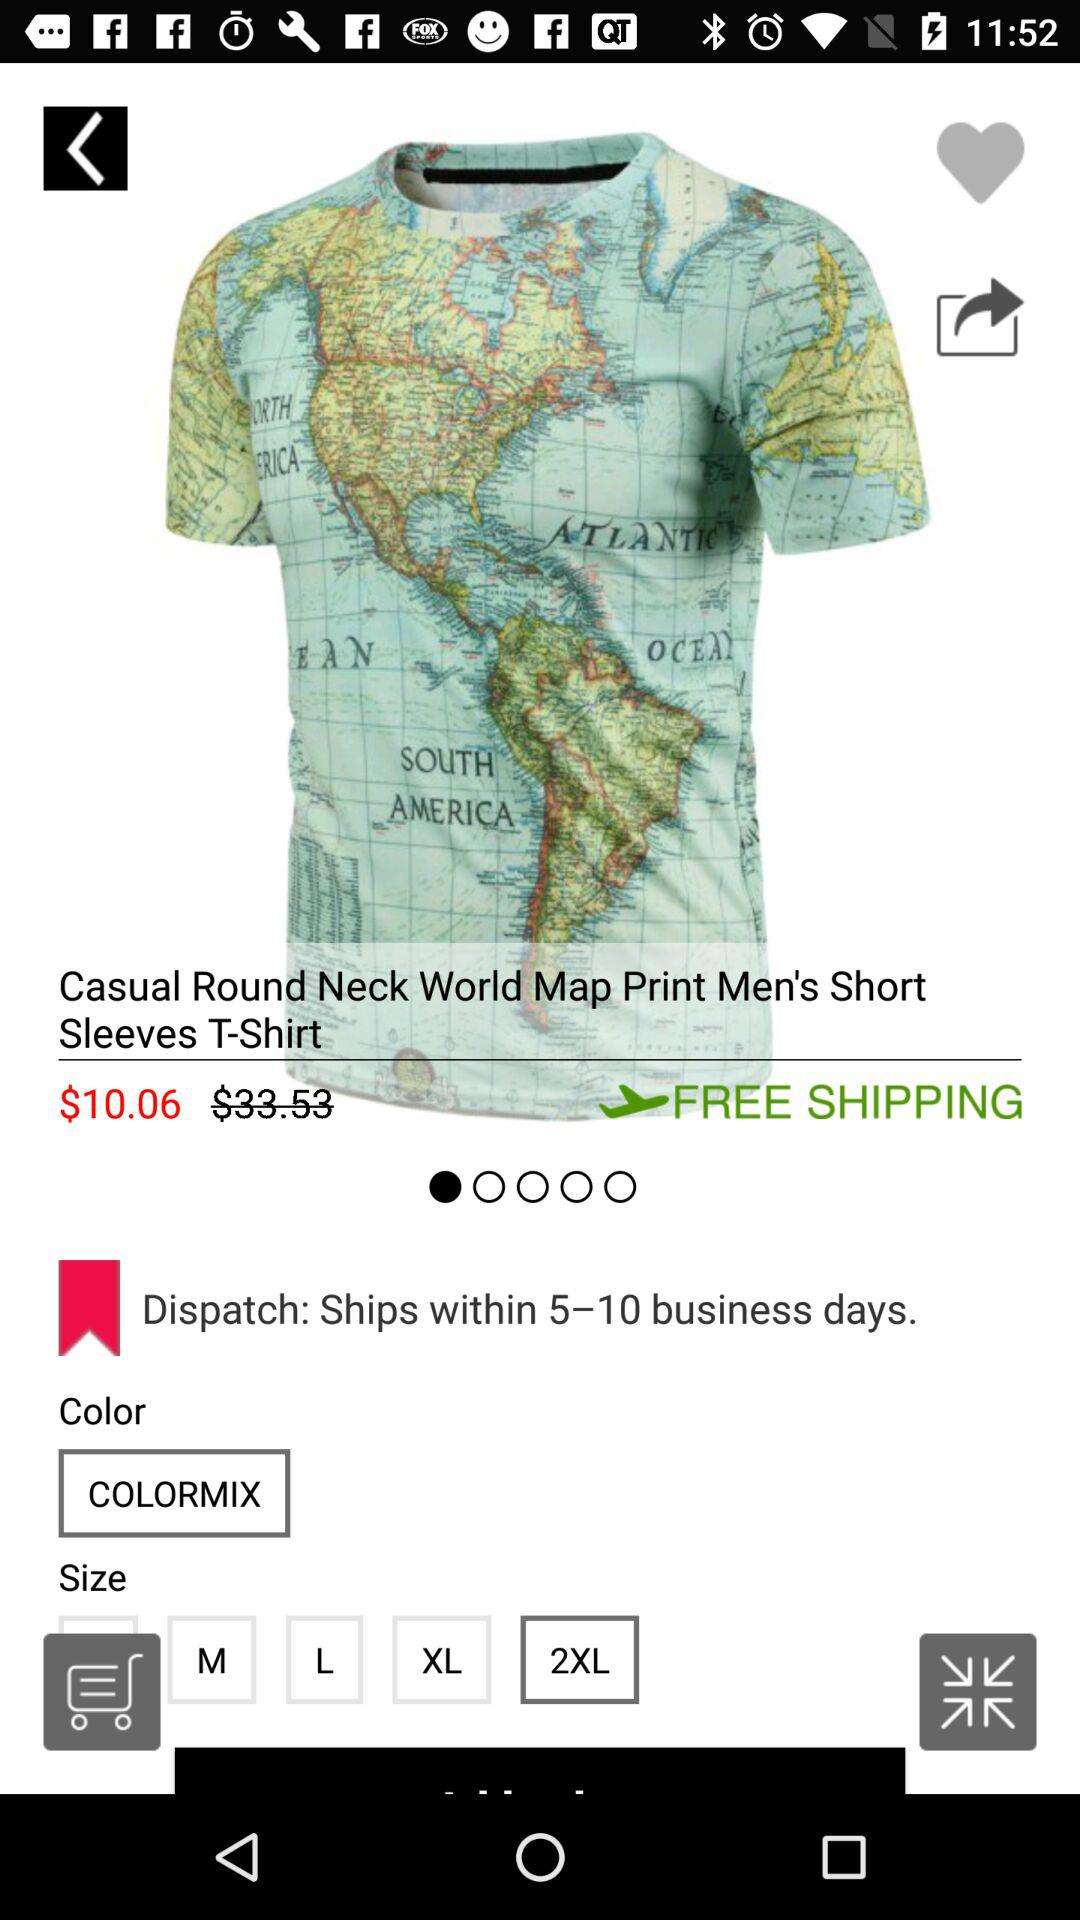What are the shipping charges? It is free of cost. 